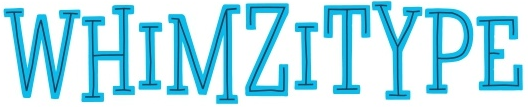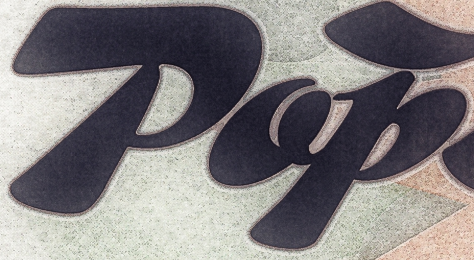Identify the words shown in these images in order, separated by a semicolon. WHIMZITYPE; Pop 